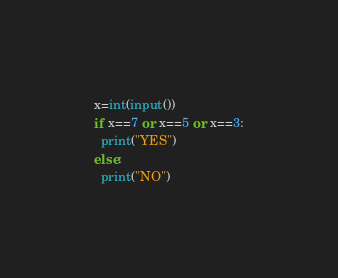Convert code to text. <code><loc_0><loc_0><loc_500><loc_500><_Python_>x=int(input())
if x==7 or x==5 or x==3:
  print("YES")
else:
  print("NO")
</code> 